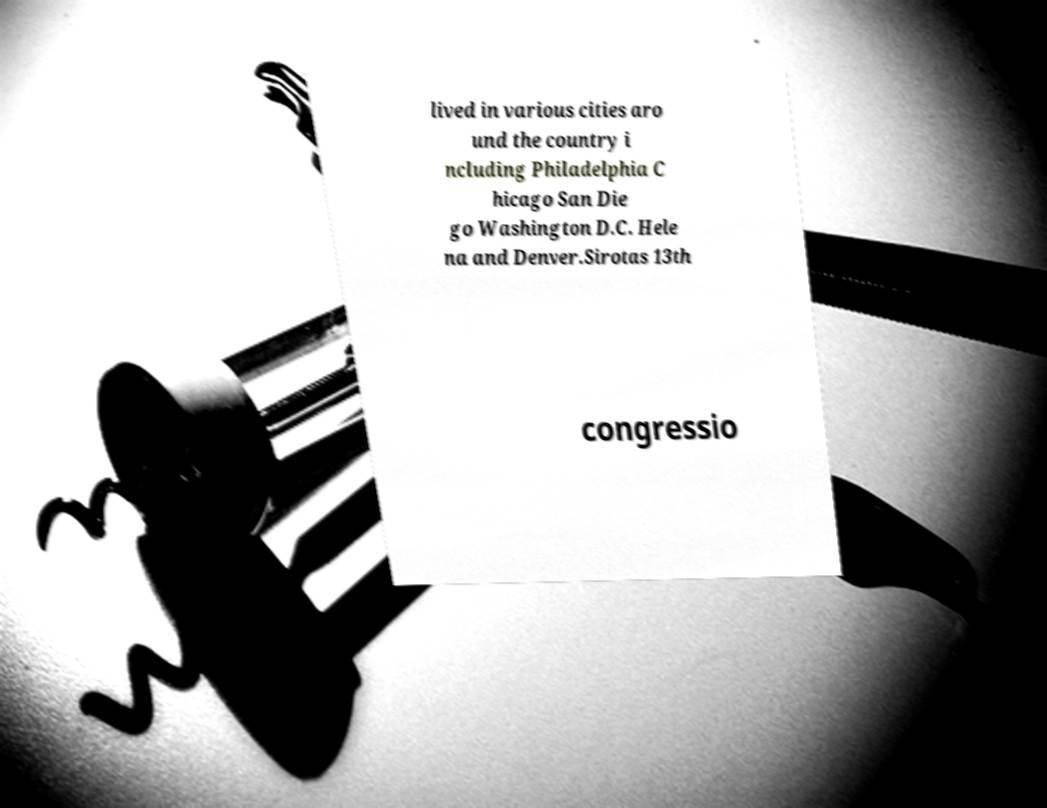Can you accurately transcribe the text from the provided image for me? lived in various cities aro und the country i ncluding Philadelphia C hicago San Die go Washington D.C. Hele na and Denver.Sirotas 13th congressio 